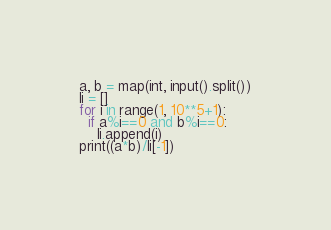<code> <loc_0><loc_0><loc_500><loc_500><_Python_>a, b = map(int, input().split())
li = []
for i in range(1, 10**5+1):
  if a%i==0 and b%i==0:
    li.append(i)
print((a*b)/li[-1])</code> 